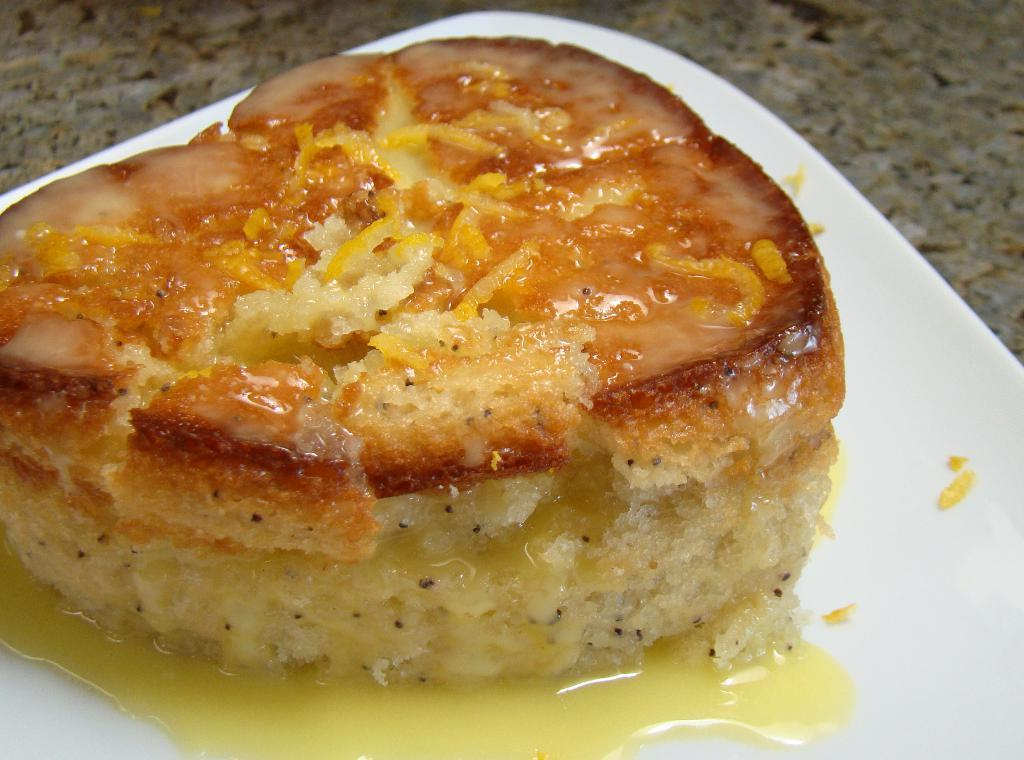What is the main subject of the image? There is a food item in the image. How is the food item presented in the image? The food item is on a plate. Where is the plate with the food item located? The plate is on a table. What type of grain can be seen growing in the image? There is no grain present in the image; it features a food item on a plate. Can you identify the actor who is serving the food in the image? There is no actor present in the image; it only shows a food item on a plate on a table. 